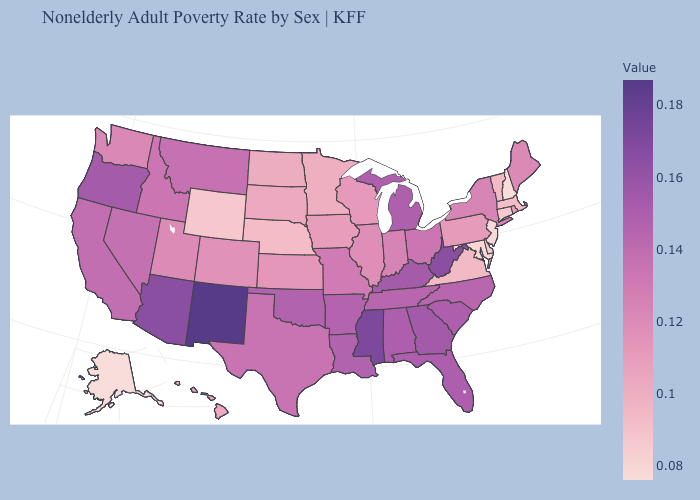Which states have the lowest value in the MidWest?
Keep it brief. Nebraska. Which states have the highest value in the USA?
Quick response, please. New Mexico. Does Mississippi have the highest value in the South?
Be succinct. Yes. 